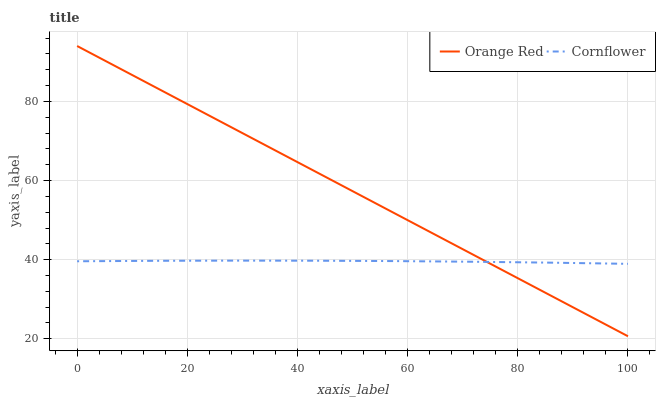Does Cornflower have the minimum area under the curve?
Answer yes or no. Yes. Does Orange Red have the maximum area under the curve?
Answer yes or no. Yes. Does Orange Red have the minimum area under the curve?
Answer yes or no. No. Is Orange Red the smoothest?
Answer yes or no. Yes. Is Cornflower the roughest?
Answer yes or no. Yes. Is Orange Red the roughest?
Answer yes or no. No. Does Orange Red have the highest value?
Answer yes or no. Yes. Does Orange Red intersect Cornflower?
Answer yes or no. Yes. Is Orange Red less than Cornflower?
Answer yes or no. No. Is Orange Red greater than Cornflower?
Answer yes or no. No. 